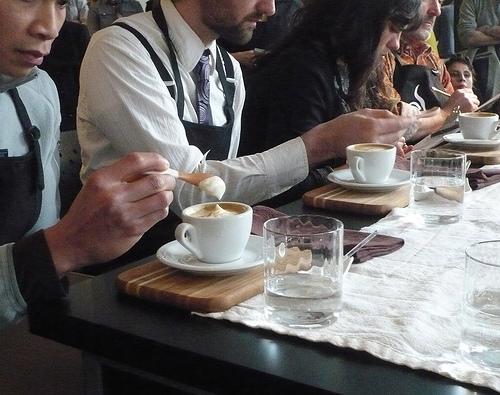<image>
Can you confirm if the tablecloth is next to the glass? No. The tablecloth is not positioned next to the glass. They are located in different areas of the scene. 